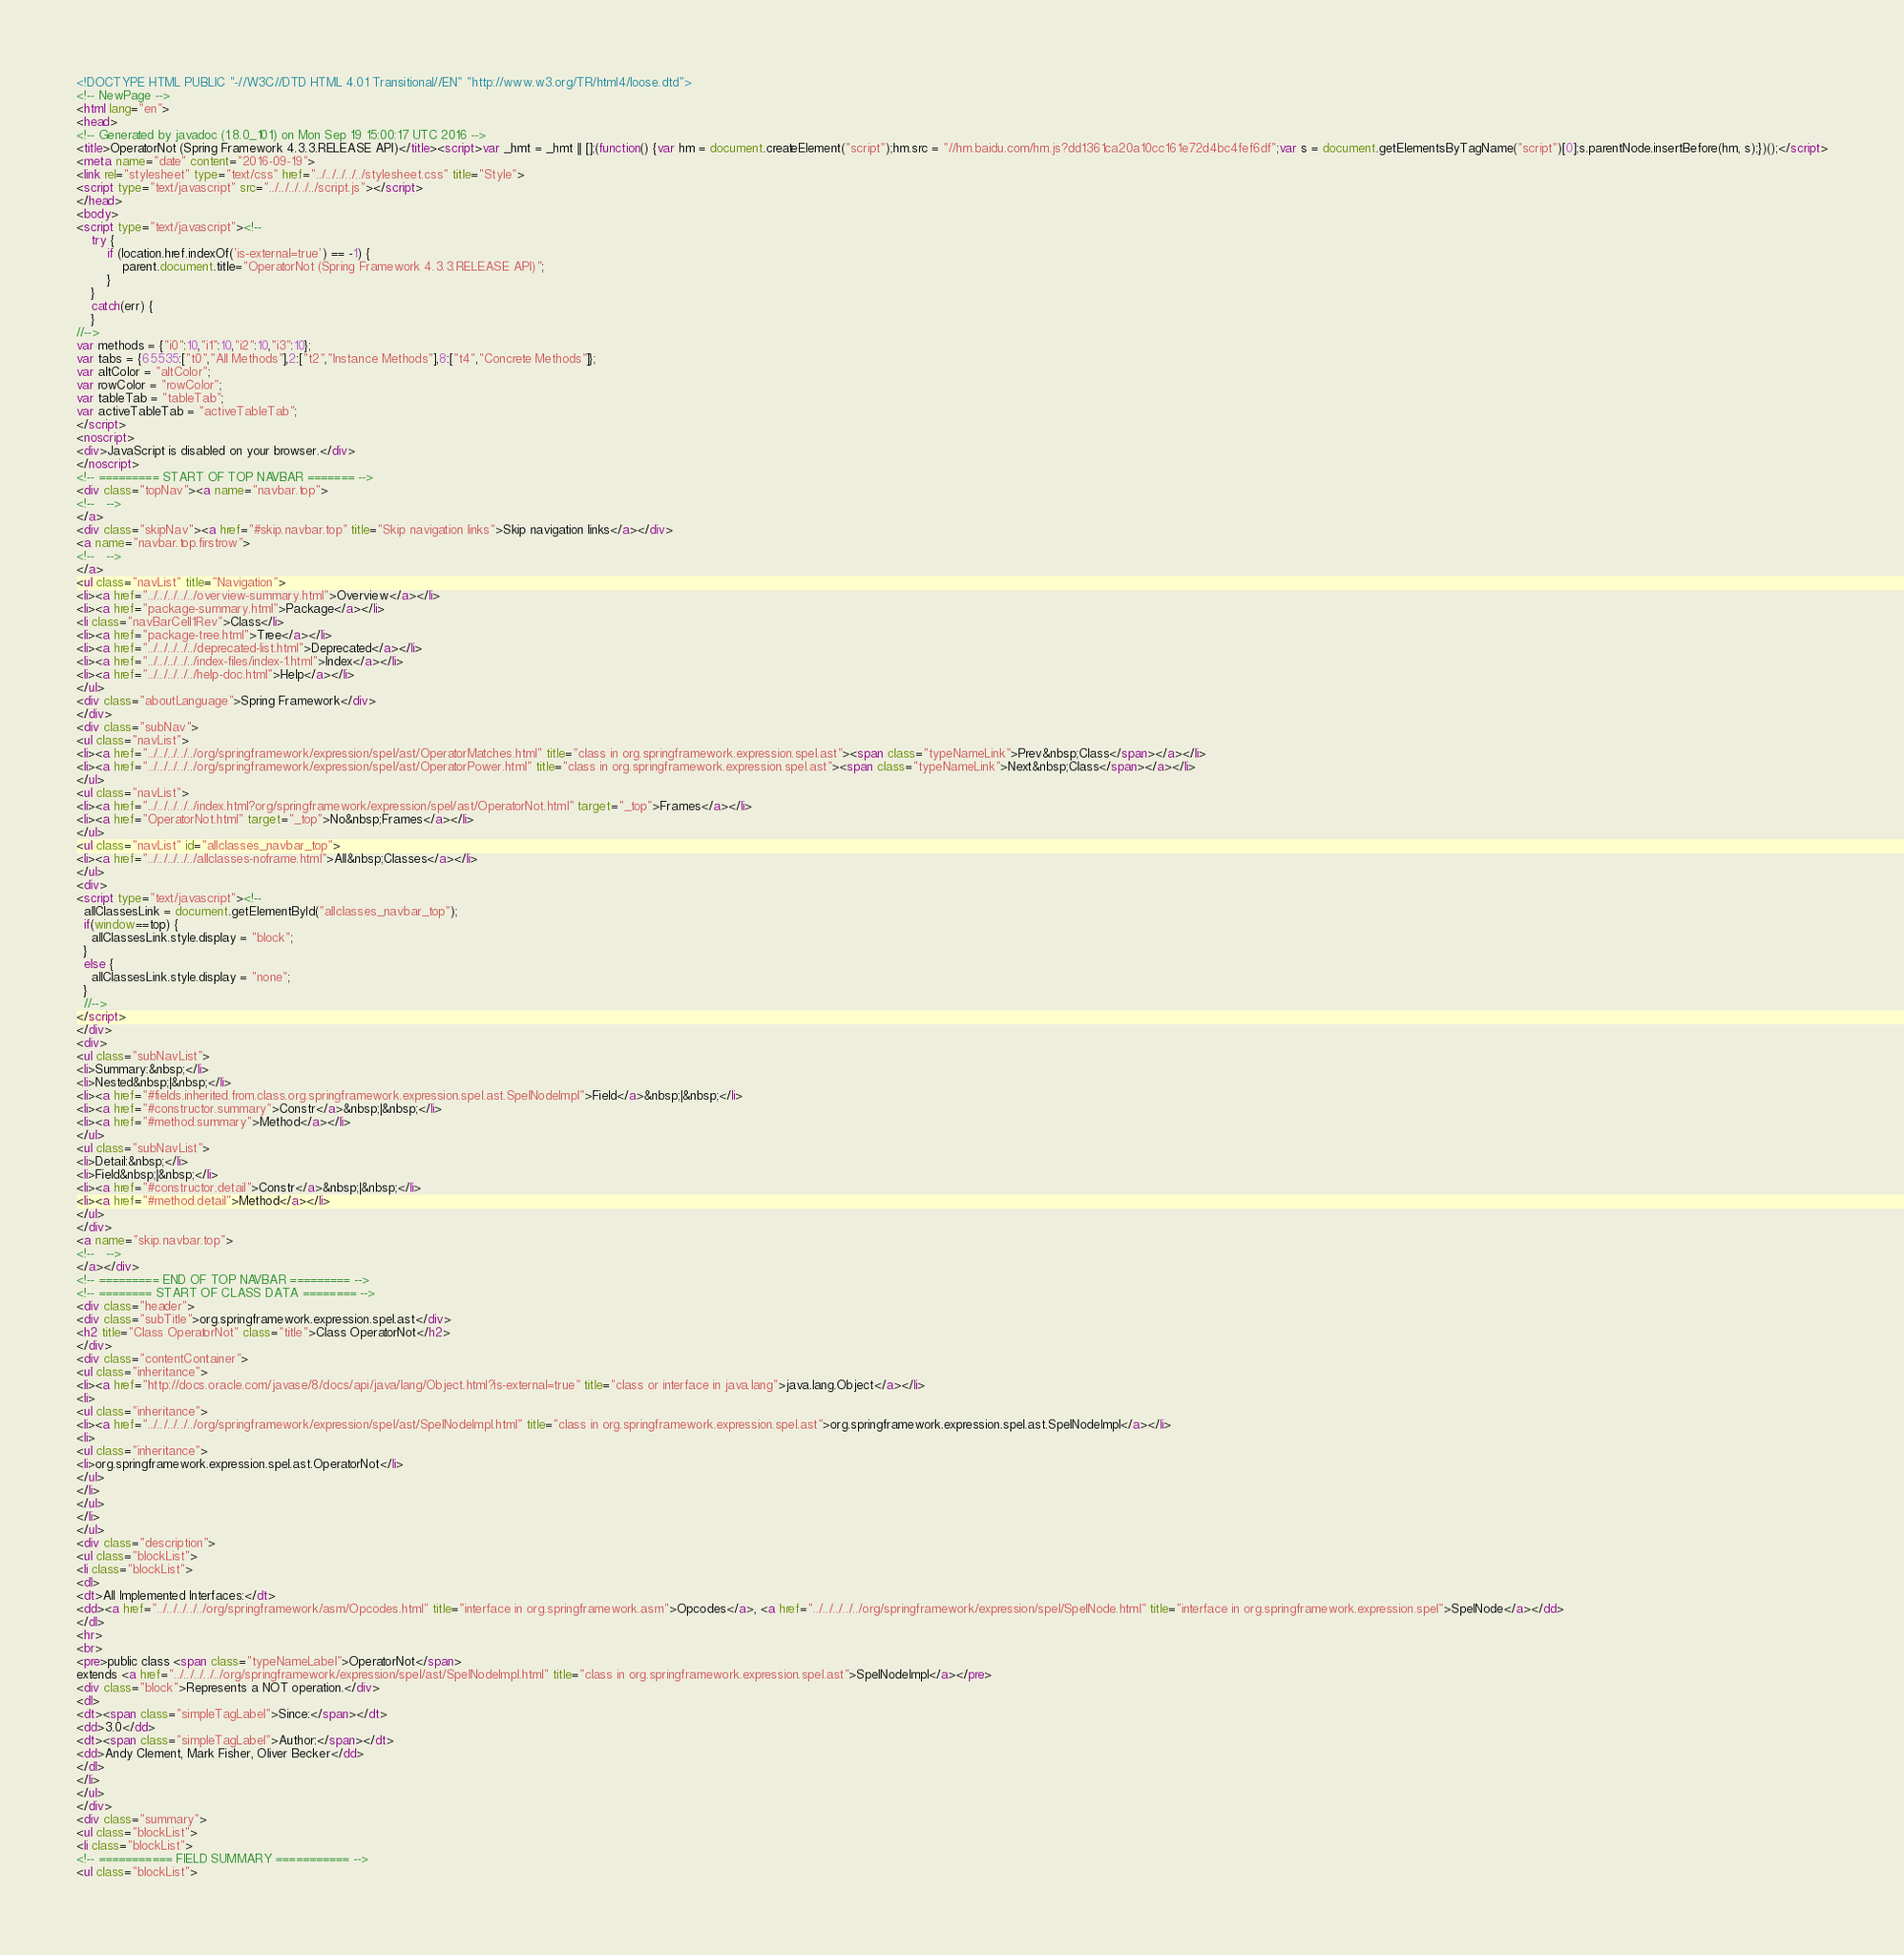Convert code to text. <code><loc_0><loc_0><loc_500><loc_500><_HTML_><!DOCTYPE HTML PUBLIC "-//W3C//DTD HTML 4.01 Transitional//EN" "http://www.w3.org/TR/html4/loose.dtd">
<!-- NewPage -->
<html lang="en">
<head>
<!-- Generated by javadoc (1.8.0_101) on Mon Sep 19 15:00:17 UTC 2016 -->
<title>OperatorNot (Spring Framework 4.3.3.RELEASE API)</title><script>var _hmt = _hmt || [];(function() {var hm = document.createElement("script");hm.src = "//hm.baidu.com/hm.js?dd1361ca20a10cc161e72d4bc4fef6df";var s = document.getElementsByTagName("script")[0];s.parentNode.insertBefore(hm, s);})();</script>
<meta name="date" content="2016-09-19">
<link rel="stylesheet" type="text/css" href="../../../../../stylesheet.css" title="Style">
<script type="text/javascript" src="../../../../../script.js"></script>
</head>
<body>
<script type="text/javascript"><!--
    try {
        if (location.href.indexOf('is-external=true') == -1) {
            parent.document.title="OperatorNot (Spring Framework 4.3.3.RELEASE API)";
        }
    }
    catch(err) {
    }
//-->
var methods = {"i0":10,"i1":10,"i2":10,"i3":10};
var tabs = {65535:["t0","All Methods"],2:["t2","Instance Methods"],8:["t4","Concrete Methods"]};
var altColor = "altColor";
var rowColor = "rowColor";
var tableTab = "tableTab";
var activeTableTab = "activeTableTab";
</script>
<noscript>
<div>JavaScript is disabled on your browser.</div>
</noscript>
<!-- ========= START OF TOP NAVBAR ======= -->
<div class="topNav"><a name="navbar.top">
<!--   -->
</a>
<div class="skipNav"><a href="#skip.navbar.top" title="Skip navigation links">Skip navigation links</a></div>
<a name="navbar.top.firstrow">
<!--   -->
</a>
<ul class="navList" title="Navigation">
<li><a href="../../../../../overview-summary.html">Overview</a></li>
<li><a href="package-summary.html">Package</a></li>
<li class="navBarCell1Rev">Class</li>
<li><a href="package-tree.html">Tree</a></li>
<li><a href="../../../../../deprecated-list.html">Deprecated</a></li>
<li><a href="../../../../../index-files/index-1.html">Index</a></li>
<li><a href="../../../../../help-doc.html">Help</a></li>
</ul>
<div class="aboutLanguage">Spring Framework</div>
</div>
<div class="subNav">
<ul class="navList">
<li><a href="../../../../../org/springframework/expression/spel/ast/OperatorMatches.html" title="class in org.springframework.expression.spel.ast"><span class="typeNameLink">Prev&nbsp;Class</span></a></li>
<li><a href="../../../../../org/springframework/expression/spel/ast/OperatorPower.html" title="class in org.springframework.expression.spel.ast"><span class="typeNameLink">Next&nbsp;Class</span></a></li>
</ul>
<ul class="navList">
<li><a href="../../../../../index.html?org/springframework/expression/spel/ast/OperatorNot.html" target="_top">Frames</a></li>
<li><a href="OperatorNot.html" target="_top">No&nbsp;Frames</a></li>
</ul>
<ul class="navList" id="allclasses_navbar_top">
<li><a href="../../../../../allclasses-noframe.html">All&nbsp;Classes</a></li>
</ul>
<div>
<script type="text/javascript"><!--
  allClassesLink = document.getElementById("allclasses_navbar_top");
  if(window==top) {
    allClassesLink.style.display = "block";
  }
  else {
    allClassesLink.style.display = "none";
  }
  //-->
</script>
</div>
<div>
<ul class="subNavList">
<li>Summary:&nbsp;</li>
<li>Nested&nbsp;|&nbsp;</li>
<li><a href="#fields.inherited.from.class.org.springframework.expression.spel.ast.SpelNodeImpl">Field</a>&nbsp;|&nbsp;</li>
<li><a href="#constructor.summary">Constr</a>&nbsp;|&nbsp;</li>
<li><a href="#method.summary">Method</a></li>
</ul>
<ul class="subNavList">
<li>Detail:&nbsp;</li>
<li>Field&nbsp;|&nbsp;</li>
<li><a href="#constructor.detail">Constr</a>&nbsp;|&nbsp;</li>
<li><a href="#method.detail">Method</a></li>
</ul>
</div>
<a name="skip.navbar.top">
<!--   -->
</a></div>
<!-- ========= END OF TOP NAVBAR ========= -->
<!-- ======== START OF CLASS DATA ======== -->
<div class="header">
<div class="subTitle">org.springframework.expression.spel.ast</div>
<h2 title="Class OperatorNot" class="title">Class OperatorNot</h2>
</div>
<div class="contentContainer">
<ul class="inheritance">
<li><a href="http://docs.oracle.com/javase/8/docs/api/java/lang/Object.html?is-external=true" title="class or interface in java.lang">java.lang.Object</a></li>
<li>
<ul class="inheritance">
<li><a href="../../../../../org/springframework/expression/spel/ast/SpelNodeImpl.html" title="class in org.springframework.expression.spel.ast">org.springframework.expression.spel.ast.SpelNodeImpl</a></li>
<li>
<ul class="inheritance">
<li>org.springframework.expression.spel.ast.OperatorNot</li>
</ul>
</li>
</ul>
</li>
</ul>
<div class="description">
<ul class="blockList">
<li class="blockList">
<dl>
<dt>All Implemented Interfaces:</dt>
<dd><a href="../../../../../org/springframework/asm/Opcodes.html" title="interface in org.springframework.asm">Opcodes</a>, <a href="../../../../../org/springframework/expression/spel/SpelNode.html" title="interface in org.springframework.expression.spel">SpelNode</a></dd>
</dl>
<hr>
<br>
<pre>public class <span class="typeNameLabel">OperatorNot</span>
extends <a href="../../../../../org/springframework/expression/spel/ast/SpelNodeImpl.html" title="class in org.springframework.expression.spel.ast">SpelNodeImpl</a></pre>
<div class="block">Represents a NOT operation.</div>
<dl>
<dt><span class="simpleTagLabel">Since:</span></dt>
<dd>3.0</dd>
<dt><span class="simpleTagLabel">Author:</span></dt>
<dd>Andy Clement, Mark Fisher, Oliver Becker</dd>
</dl>
</li>
</ul>
</div>
<div class="summary">
<ul class="blockList">
<li class="blockList">
<!-- =========== FIELD SUMMARY =========== -->
<ul class="blockList"></code> 